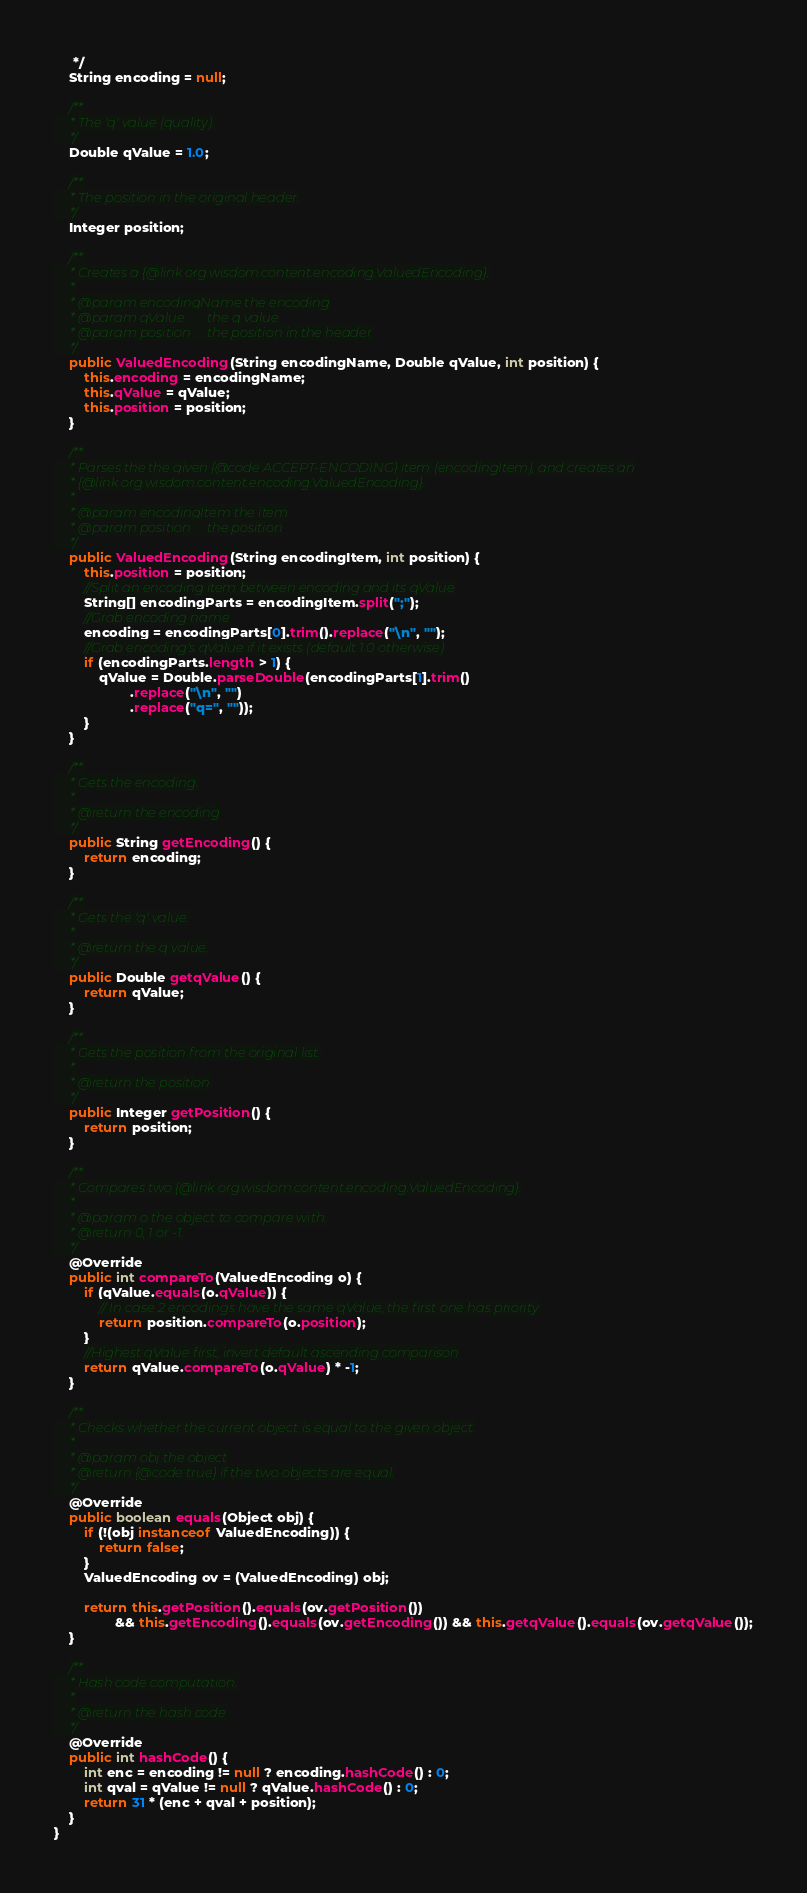<code> <loc_0><loc_0><loc_500><loc_500><_Java_>     */
    String encoding = null;

    /**
     * The 'q' value (quality).
     */
    Double qValue = 1.0;

    /**
     * The position in the original header.
     */
    Integer position;

    /**
     * Creates a {@link org.wisdom.content.encoding.ValuedEncoding}.
     *
     * @param encodingName the encoding
     * @param qValue       the q value
     * @param position     the position in the header
     */
    public ValuedEncoding(String encodingName, Double qValue, int position) {
        this.encoding = encodingName;
        this.qValue = qValue;
        this.position = position;
    }

    /**
     * Parses the the given {@code ACCEPT-ENCODING} item (encodingItem), and creates an
     * {@link org.wisdom.content.encoding.ValuedEncoding}.
     *
     * @param encodingItem the item
     * @param position     the position
     */
    public ValuedEncoding(String encodingItem, int position) {
        this.position = position;
        //Split an encoding item between encoding and its qValue
        String[] encodingParts = encodingItem.split(";");
        //Grab encoding name
        encoding = encodingParts[0].trim().replace("\n", "");
        //Grab encoding's qValue if it exists (default 1.0 otherwise)
        if (encodingParts.length > 1) {
            qValue = Double.parseDouble(encodingParts[1].trim()
                    .replace("\n", "")
                    .replace("q=", ""));
        }
    }

    /**
     * Gets the encoding.
     *
     * @return the encoding
     */
    public String getEncoding() {
        return encoding;
    }

    /**
     * Gets the 'q' value.
     *
     * @return the q value.
     */
    public Double getqValue() {
        return qValue;
    }

    /**
     * Gets the position from the original list.
     *
     * @return the position
     */
    public Integer getPosition() {
        return position;
    }

    /**
     * Compares two {@link org.wisdom.content.encoding.ValuedEncoding}.
     *
     * @param o the object to compare with.
     * @return 0, 1 or -1.
     */
    @Override
    public int compareTo(ValuedEncoding o) {
        if (qValue.equals(o.qValue)) {
            // In case 2 encodings have the same qValue, the first one has priority
            return position.compareTo(o.position);
        }
        //Highest qValue first, invert default ascending comparison
        return qValue.compareTo(o.qValue) * -1;
    }

    /**
     * Checks whether the current object is equal to the given object.
     *
     * @param obj the object
     * @return {@code true} if the two objects are equal.
     */
    @Override
    public boolean equals(Object obj) {
        if (!(obj instanceof ValuedEncoding)) {
            return false;
        }
        ValuedEncoding ov = (ValuedEncoding) obj;

        return this.getPosition().equals(ov.getPosition())
                && this.getEncoding().equals(ov.getEncoding()) && this.getqValue().equals(ov.getqValue());
    }

    /**
     * Hash code computation.
     *
     * @return the hash code
     */
    @Override
    public int hashCode() {
        int enc = encoding != null ? encoding.hashCode() : 0;
        int qval = qValue != null ? qValue.hashCode() : 0;
        return 31 * (enc + qval + position);
    }
}</code> 